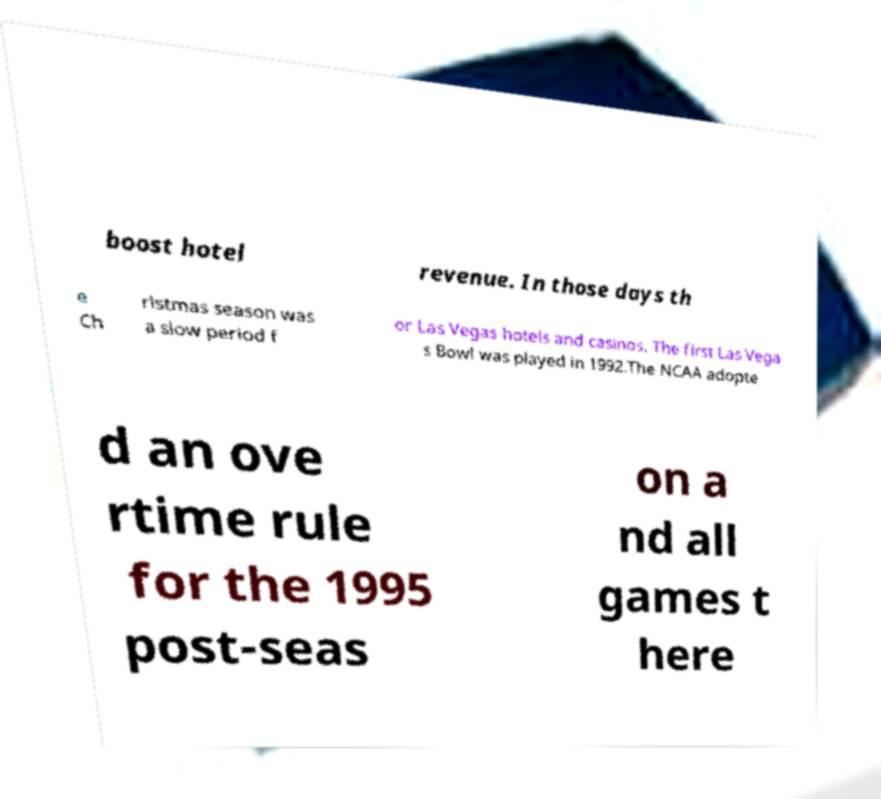What messages or text are displayed in this image? I need them in a readable, typed format. boost hotel revenue. In those days th e Ch ristmas season was a slow period f or Las Vegas hotels and casinos. The first Las Vega s Bowl was played in 1992.The NCAA adopte d an ove rtime rule for the 1995 post-seas on a nd all games t here 